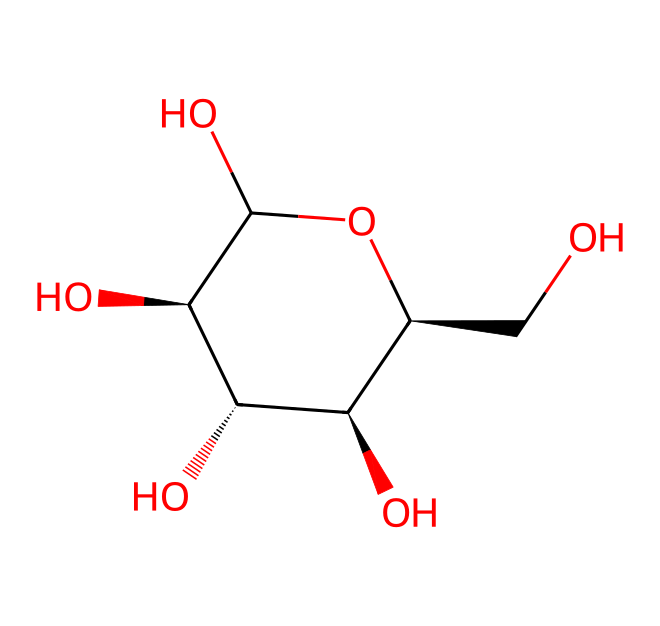How many carbon atoms are in the glucose structure? To determine the number of carbon atoms, we can analyze the SMILES representation. The structure shows several 'C' symbols, indicating carbon atoms. By counting each 'C,' we find that there are six carbon atoms present in the structure.
Answer: six What is the total number of hydroxyl groups in glucose? The presence of hydroxyl groups is indicated by 'O' that are connected to carbon atoms with 'C-O' bonds. By examining the structure, we can see there are five hydroxyl groups.
Answer: five What type of carbohydrate is represented by this structure? The structure of glucose indicates that it has a simple sugar composition with a ring structure, classifying it as a monosaccharide.
Answer: monosaccharide How many stereocenters are present in glucose? A stereocenter is a carbon atom bonded to four different substituents. In the rendered glucose structure, through careful analysis, we identify four carbon atoms that meet this criterion, indicating there are four stereocenters.
Answer: four What functional groups are present in glucose? The functional groups in glucose include hydroxyl groups (-OH) as evidenced by the numerous 'O' and the structure's overall appearance, confirming that these are the primary functional groups of interest.
Answer: hydroxyl groups 